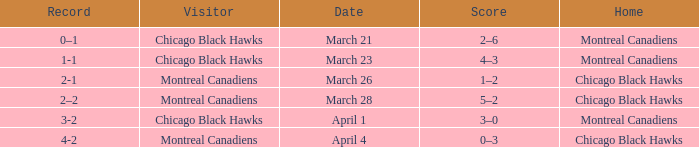What is the score for the team with a record of 2-1? 1–2. Can you give me this table as a dict? {'header': ['Record', 'Visitor', 'Date', 'Score', 'Home'], 'rows': [['0–1', 'Chicago Black Hawks', 'March 21', '2–6', 'Montreal Canadiens'], ['1-1', 'Chicago Black Hawks', 'March 23', '4–3', 'Montreal Canadiens'], ['2-1', 'Montreal Canadiens', 'March 26', '1–2', 'Chicago Black Hawks'], ['2–2', 'Montreal Canadiens', 'March 28', '5–2', 'Chicago Black Hawks'], ['3-2', 'Chicago Black Hawks', 'April 1', '3–0', 'Montreal Canadiens'], ['4-2', 'Montreal Canadiens', 'April 4', '0–3', 'Chicago Black Hawks']]} 